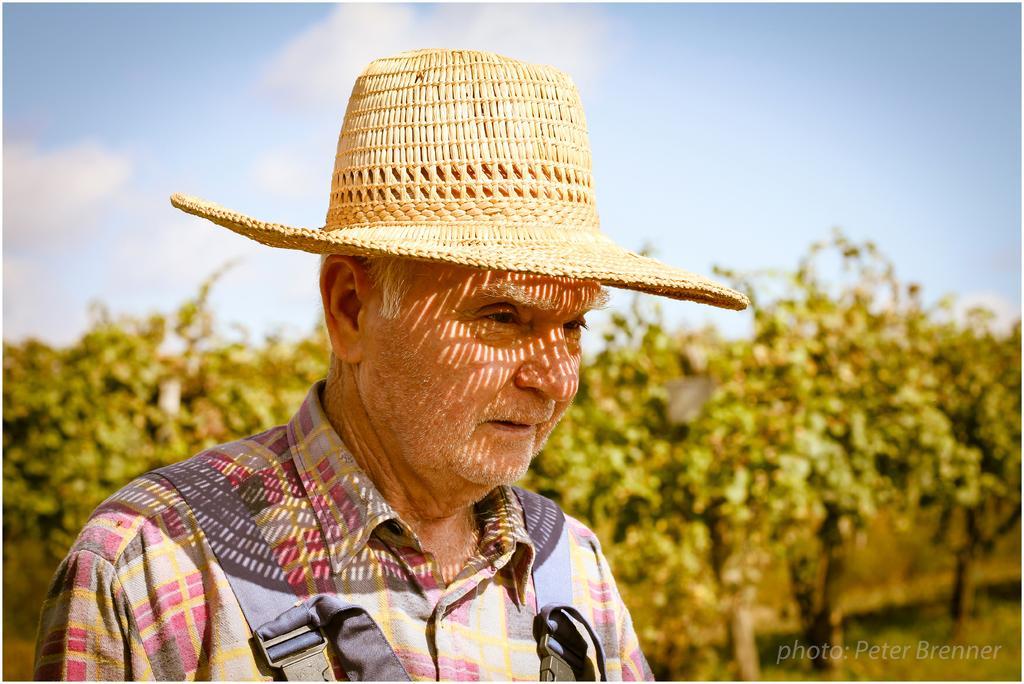In one or two sentences, can you explain what this image depicts? In this image, we can see a man wearing hat and in the background, there are trees. 